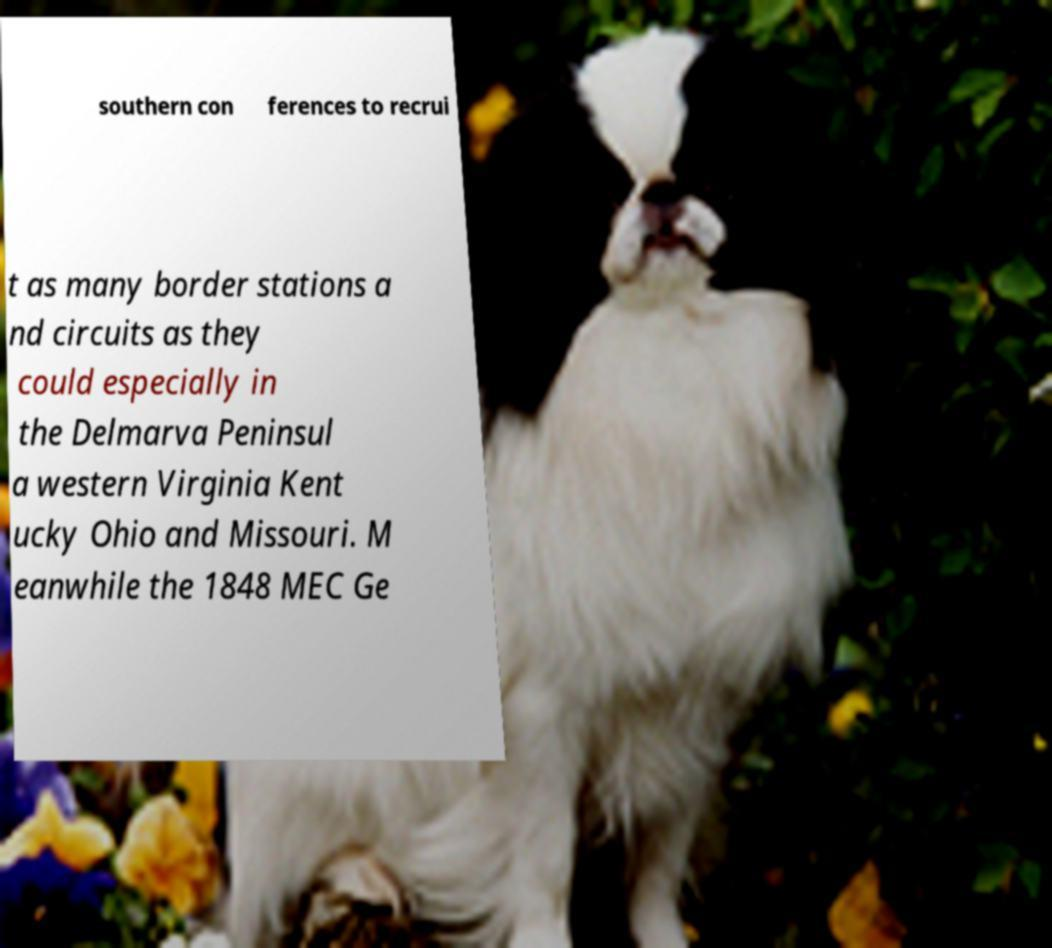I need the written content from this picture converted into text. Can you do that? southern con ferences to recrui t as many border stations a nd circuits as they could especially in the Delmarva Peninsul a western Virginia Kent ucky Ohio and Missouri. M eanwhile the 1848 MEC Ge 